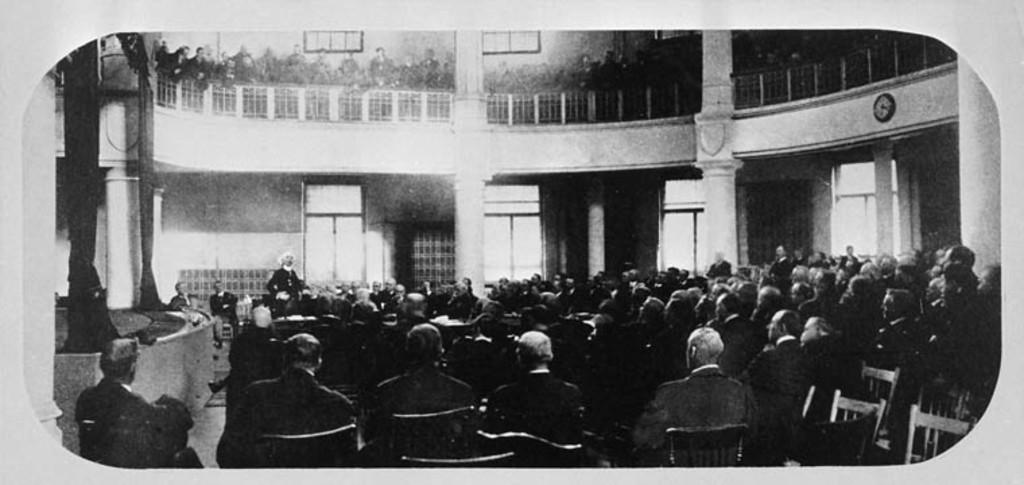Can you describe this image briefly? Here in this picture we can see an auditorium full of people sitting on chairs present over there and we can see one person standing and speaking something to all of them and on the left side we can see curtains present on the stage over there and at the top also we can see people sitting all over there, we can see windows present in the building over there. 